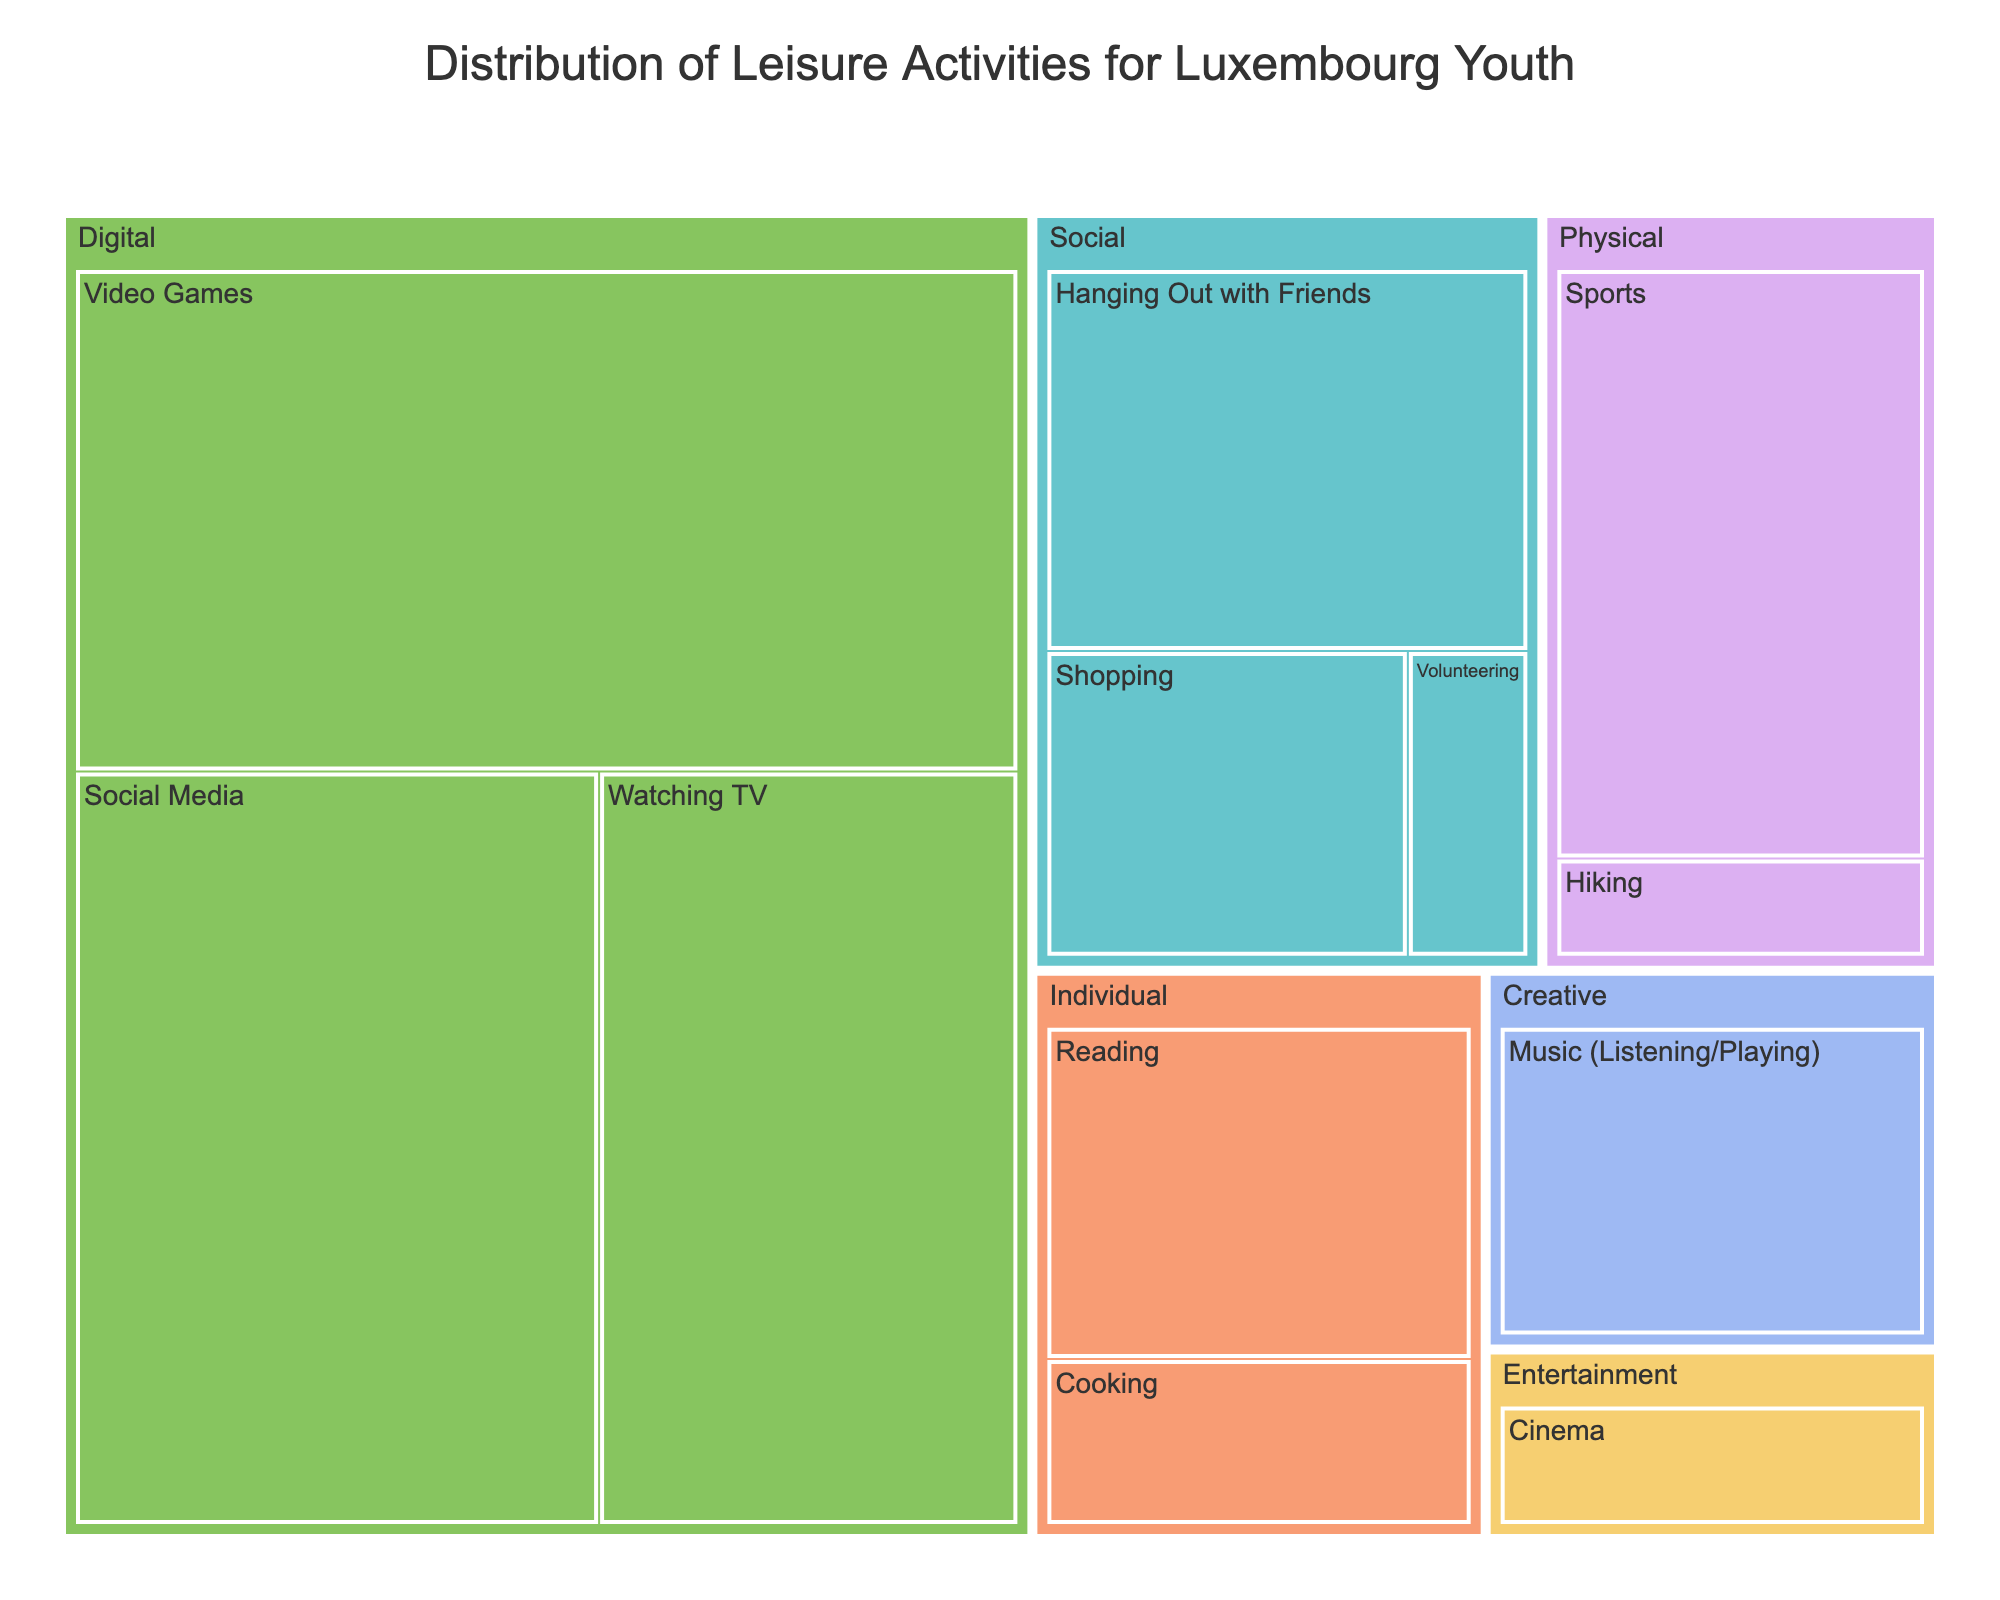What is the title of the treemap? The title is generally located at the top of the figure. It provides an overview of the data being visualized.
Answer: Distribution of Leisure Activities for Luxembourg Youth Which activity requires the most hours spent? By observing the blocks, the largest block signifies the activity with the most hours.
Answer: Video Games How many hours are spent on Social Media? The blocks under the 'Digital' category show the time. Find and sum the hours for Social Media within the 'Digital' category.
Answer: 10 Compare the hours spent on Sports to hours spent on Shopping. Which one has more hours? Locate the blocks for Sports and Shopping and compare their sizes or check their labels.
Answer: Sports How much time is spent on Individual activities in total? Sum the hours of activities in the 'Individual' category (Reading and Cooking).
Answer: 6 Which category has the least amount of hours combined? Sum the hours for each category and find the one with the lowest total.
Answer: Social What are the activities under the 'Creative' category? Check within the 'Creative' category to see the names of the activities grouped there.
Answer: Music (Listening/Playing) Which category do 'Video Games' and 'Watching TV' belong to? Observe the parent category above both 'Video Games' and 'Watching TV'.
Answer: Digital What is the difference in hours spent between 'Hiking' and 'Cinema'? Subtract the hours spent on 'Hiking' from those spent on 'Cinema'.
Answer: 1 What are the hours spent on hanging out with friends compared to hours on physical activities? Sum the hours spent on all activities under the 'Physical' category and compare it to the hours for 'Hanging Out with Friends'.
Answer: 6 vs 5 